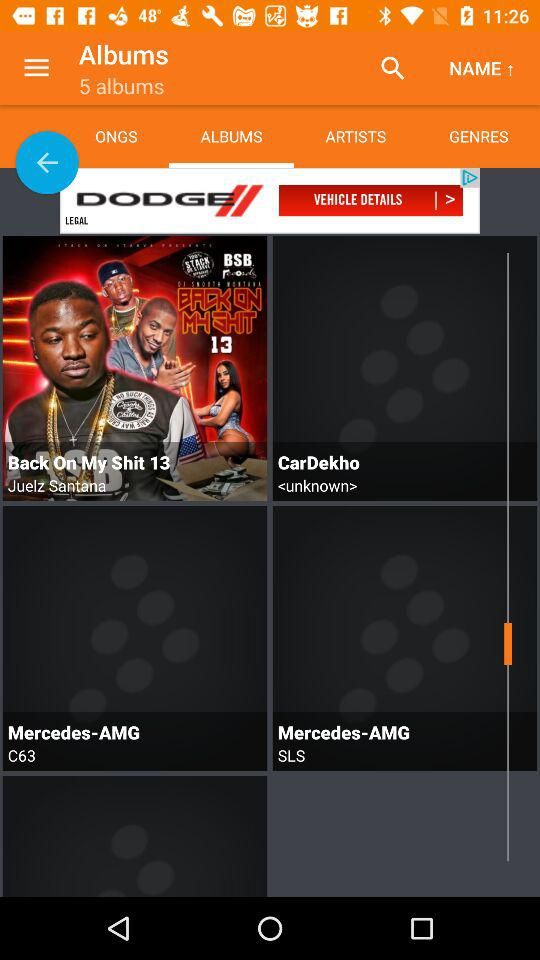Which tab am I on? You are on "ALBUMS" tab. 